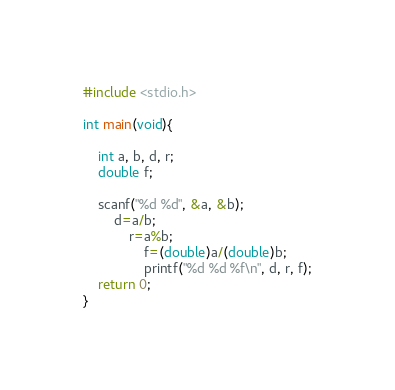<code> <loc_0><loc_0><loc_500><loc_500><_C_>#include <stdio.h>

int main(void){

	int a, b, d, r;
	double f;

	scanf("%d %d", &a, &b);
		d=a/b;
			r=a%b;
				f=(double)a/(double)b;
				printf("%d %d %f\n", d, r, f);
	return 0;
}</code> 